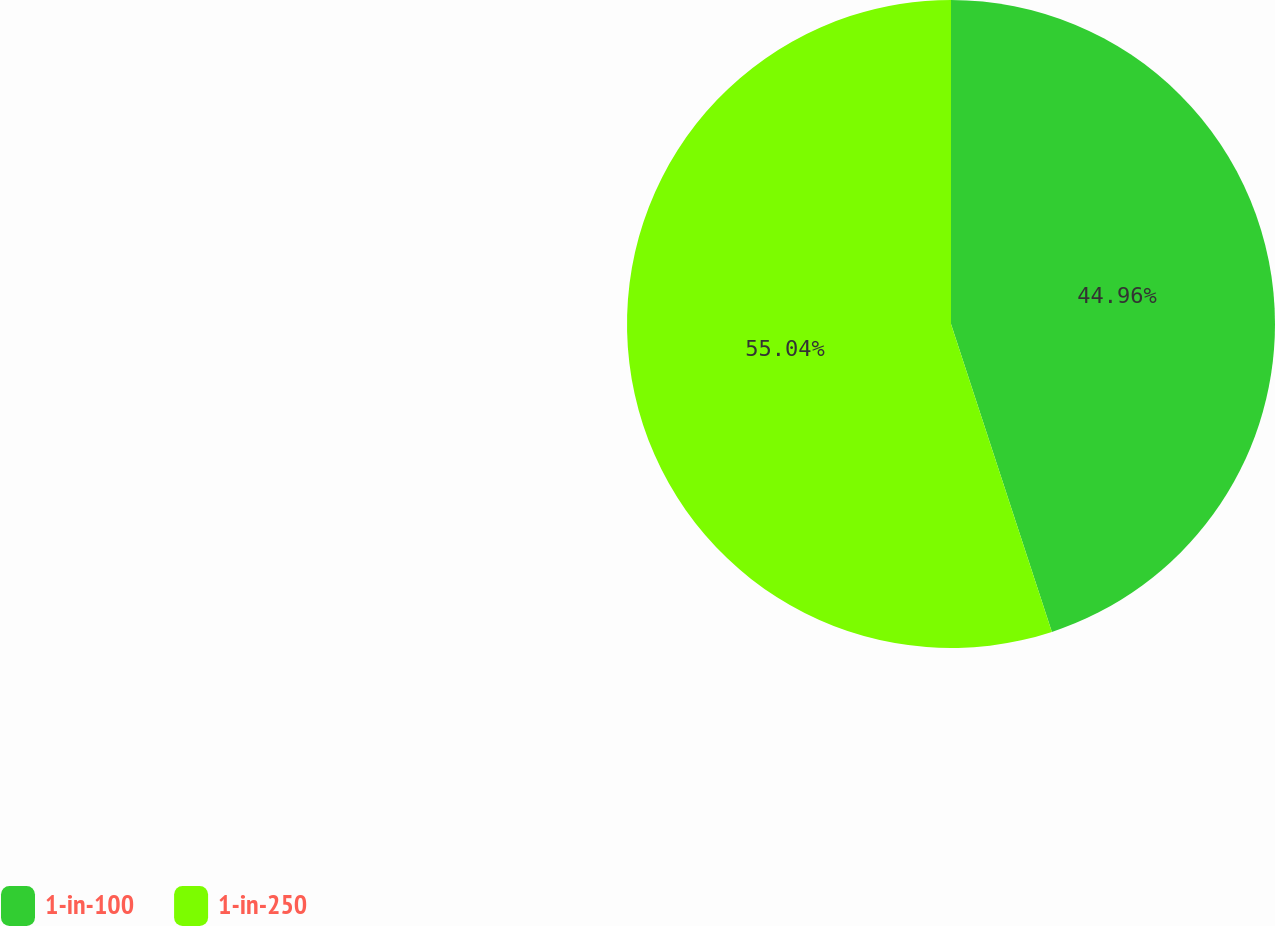<chart> <loc_0><loc_0><loc_500><loc_500><pie_chart><fcel>1-in-100<fcel>1-in-250<nl><fcel>44.96%<fcel>55.04%<nl></chart> 